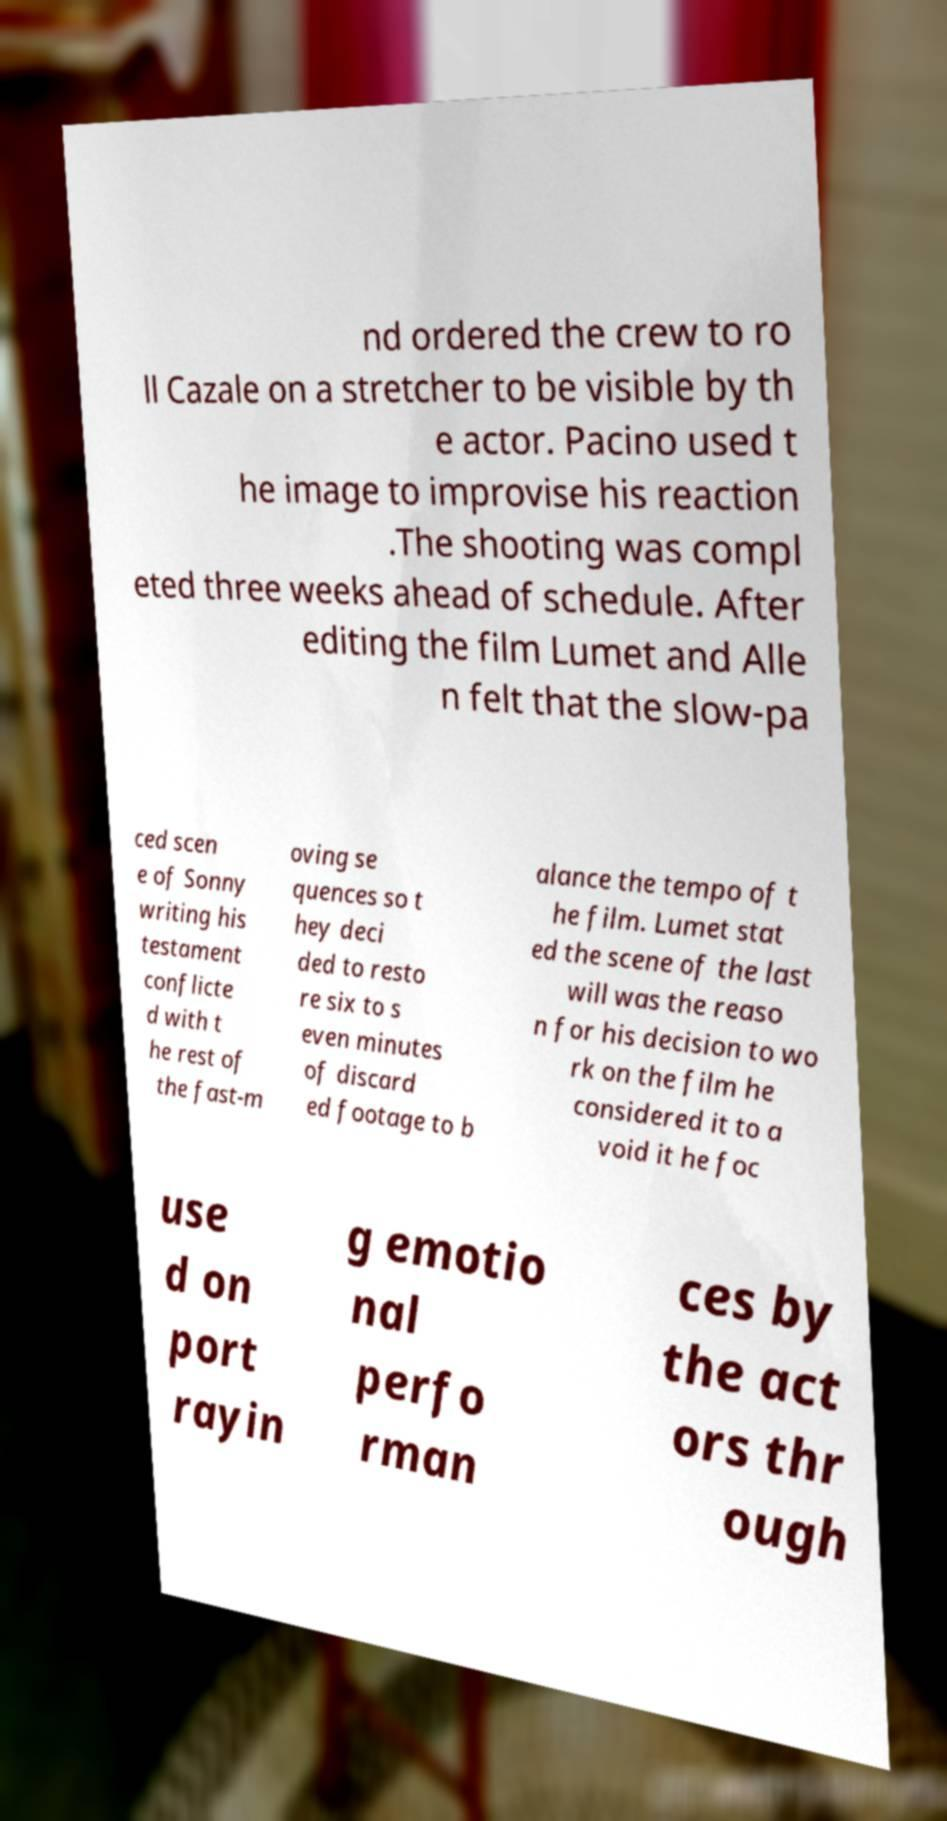Could you assist in decoding the text presented in this image and type it out clearly? nd ordered the crew to ro ll Cazale on a stretcher to be visible by th e actor. Pacino used t he image to improvise his reaction .The shooting was compl eted three weeks ahead of schedule. After editing the film Lumet and Alle n felt that the slow-pa ced scen e of Sonny writing his testament conflicte d with t he rest of the fast-m oving se quences so t hey deci ded to resto re six to s even minutes of discard ed footage to b alance the tempo of t he film. Lumet stat ed the scene of the last will was the reaso n for his decision to wo rk on the film he considered it to a void it he foc use d on port rayin g emotio nal perfo rman ces by the act ors thr ough 